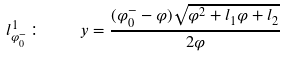Convert formula to latex. <formula><loc_0><loc_0><loc_500><loc_500>l _ { \varphi _ { 0 } ^ { - } } ^ { 1 } \colon \quad y = \frac { ( \varphi _ { 0 } ^ { - } - \varphi ) \sqrt { \varphi ^ { 2 } + l _ { 1 } \varphi + l _ { 2 } } } { 2 \varphi }</formula> 